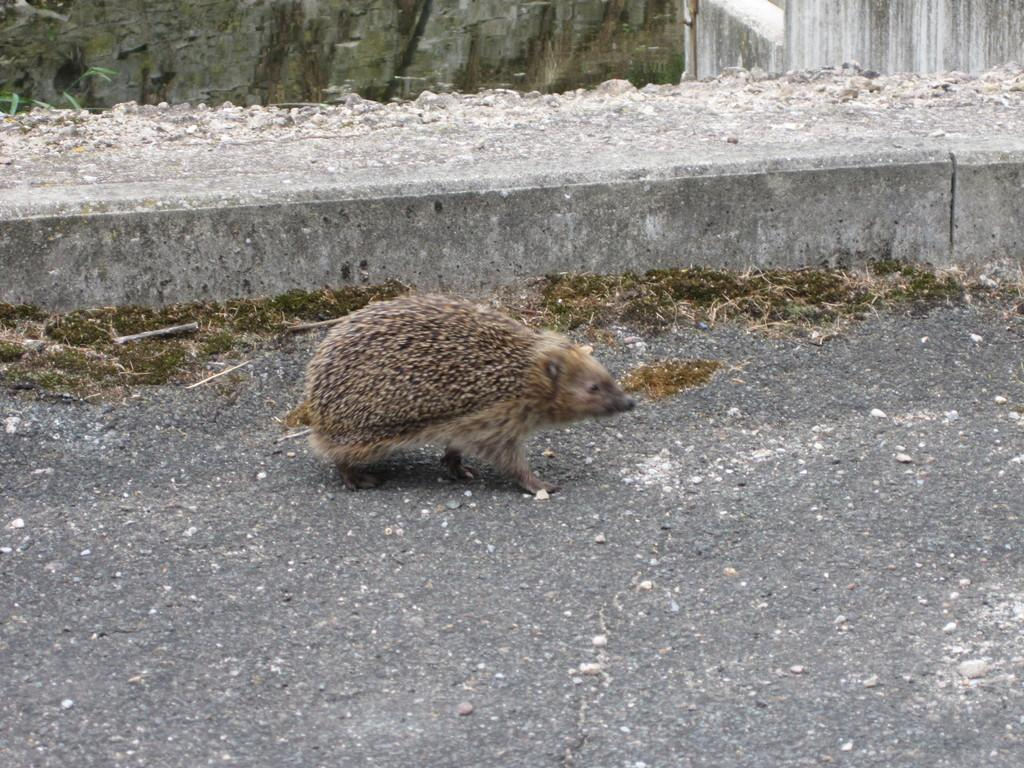What is the main subject in the middle of the image? There is an animal in the middle of the image. What can be seen on the right side of the image? There are walls on the right side of the image. What type of knee can be seen in the image? There is no knee present in the image. What type of meat is being prepared in the image? There is no meat or any indication of food preparation in the image. 